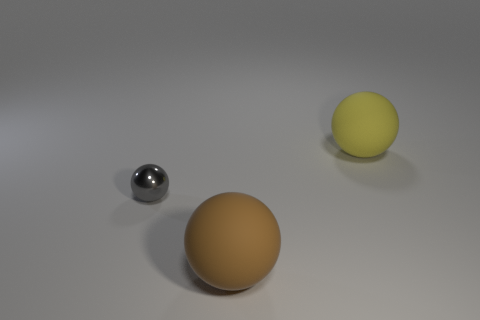Is there anything else that has the same material as the gray object?
Your answer should be compact. No. The ball that is left of the brown matte sphere is what color?
Your response must be concise. Gray. Is there anything else of the same color as the tiny metal ball?
Keep it short and to the point. No. Is the size of the brown ball the same as the gray metal object?
Your response must be concise. No. There is a sphere that is in front of the yellow rubber ball and to the right of the gray shiny object; what is its size?
Offer a very short reply. Large. How many gray balls have the same material as the yellow ball?
Provide a succinct answer. 0. The tiny sphere is what color?
Provide a succinct answer. Gray. How many objects are either matte spheres in front of the small object or balls?
Offer a terse response. 3. Is there another big matte thing of the same shape as the yellow rubber object?
Ensure brevity in your answer.  Yes. The brown thing that is the same size as the yellow rubber thing is what shape?
Your answer should be compact. Sphere. 